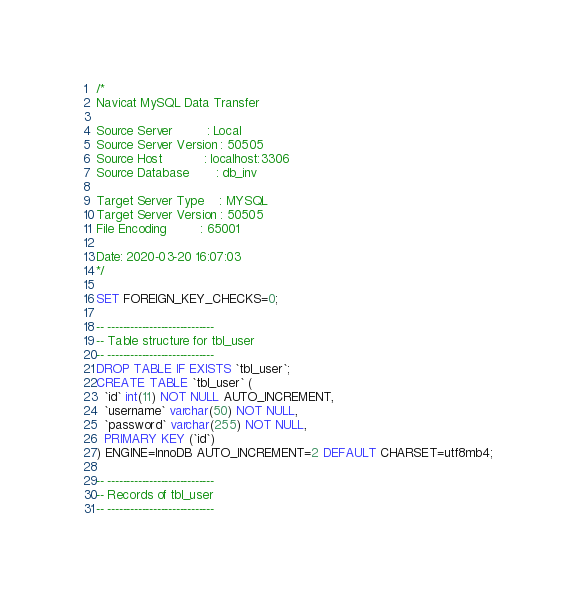<code> <loc_0><loc_0><loc_500><loc_500><_SQL_>/*
Navicat MySQL Data Transfer

Source Server         : Local
Source Server Version : 50505
Source Host           : localhost:3306
Source Database       : db_inv

Target Server Type    : MYSQL
Target Server Version : 50505
File Encoding         : 65001

Date: 2020-03-20 16:07:03
*/

SET FOREIGN_KEY_CHECKS=0;

-- ----------------------------
-- Table structure for tbl_user
-- ----------------------------
DROP TABLE IF EXISTS `tbl_user`;
CREATE TABLE `tbl_user` (
  `id` int(11) NOT NULL AUTO_INCREMENT,
  `username` varchar(50) NOT NULL,
  `password` varchar(255) NOT NULL,
  PRIMARY KEY (`id`)
) ENGINE=InnoDB AUTO_INCREMENT=2 DEFAULT CHARSET=utf8mb4;

-- ----------------------------
-- Records of tbl_user
-- ----------------------------</code> 